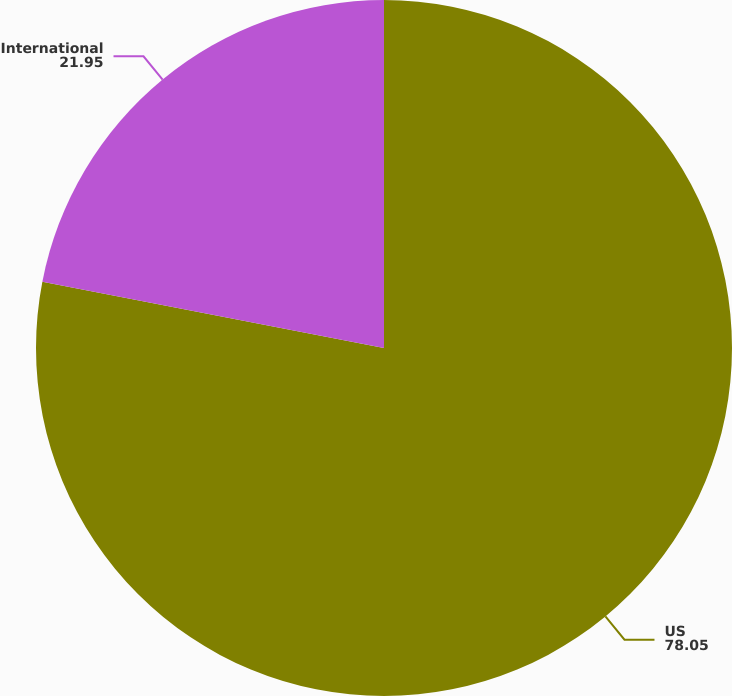Convert chart. <chart><loc_0><loc_0><loc_500><loc_500><pie_chart><fcel>US<fcel>International<nl><fcel>78.05%<fcel>21.95%<nl></chart> 